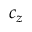<formula> <loc_0><loc_0><loc_500><loc_500>c _ { z }</formula> 